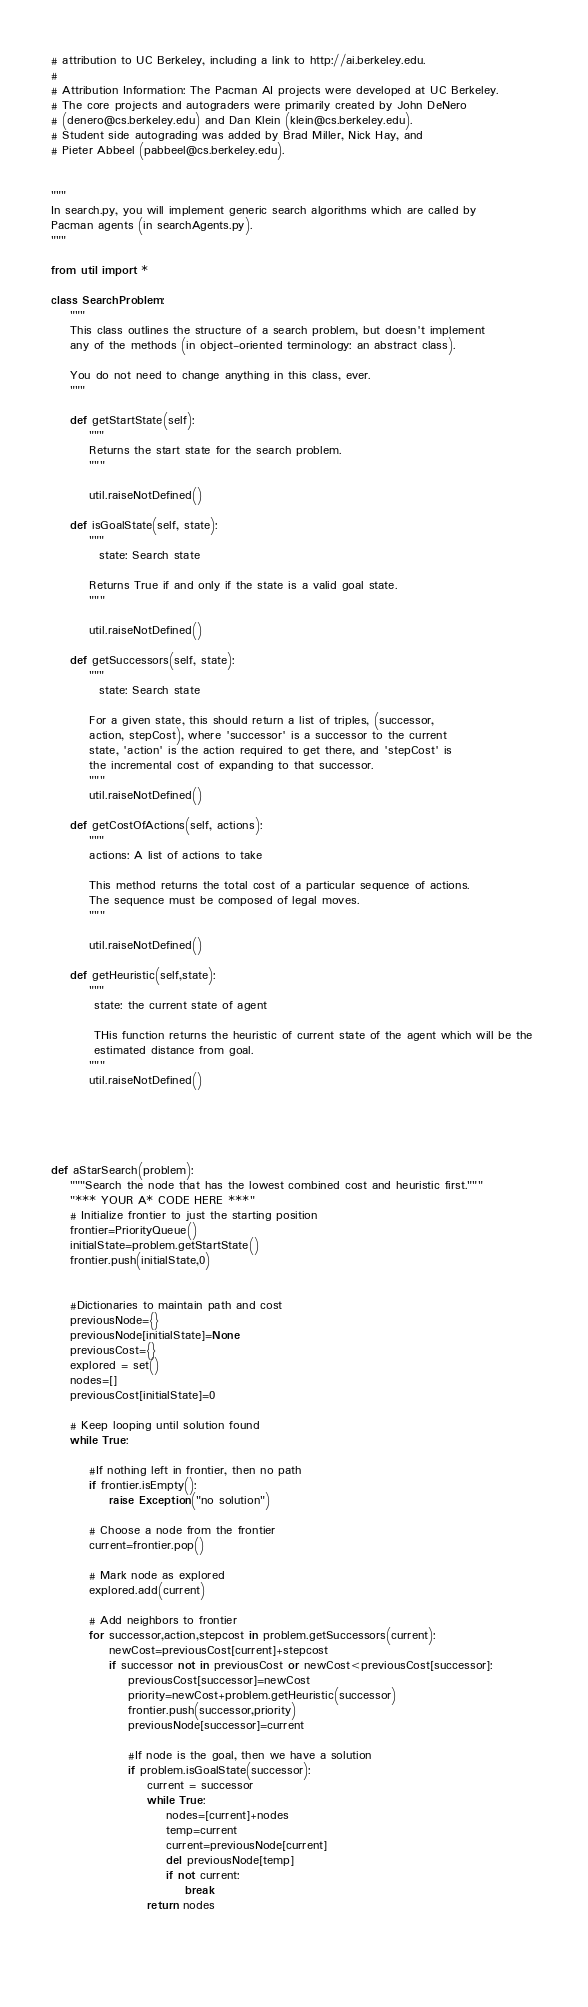Convert code to text. <code><loc_0><loc_0><loc_500><loc_500><_Python_># attribution to UC Berkeley, including a link to http://ai.berkeley.edu.
# 
# Attribution Information: The Pacman AI projects were developed at UC Berkeley.
# The core projects and autograders were primarily created by John DeNero
# (denero@cs.berkeley.edu) and Dan Klein (klein@cs.berkeley.edu).
# Student side autograding was added by Brad Miller, Nick Hay, and
# Pieter Abbeel (pabbeel@cs.berkeley.edu).


"""
In search.py, you will implement generic search algorithms which are called by
Pacman agents (in searchAgents.py).
"""

from util import *

class SearchProblem:
    """
    This class outlines the structure of a search problem, but doesn't implement
    any of the methods (in object-oriented terminology: an abstract class).

    You do not need to change anything in this class, ever.
    """

    def getStartState(self):
        """
        Returns the start state for the search problem.
        """
       
        util.raiseNotDefined()

    def isGoalState(self, state):
        """
          state: Search state

        Returns True if and only if the state is a valid goal state.
        """

        util.raiseNotDefined()

    def getSuccessors(self, state):
        """
          state: Search state

        For a given state, this should return a list of triples, (successor,
        action, stepCost), where 'successor' is a successor to the current
        state, 'action' is the action required to get there, and 'stepCost' is
        the incremental cost of expanding to that successor.
        """
        util.raiseNotDefined()

    def getCostOfActions(self, actions):
        """
        actions: A list of actions to take

        This method returns the total cost of a particular sequence of actions.
        The sequence must be composed of legal moves.
        """

        util.raiseNotDefined()
        
    def getHeuristic(self,state):
        """
         state: the current state of agent

         THis function returns the heuristic of current state of the agent which will be the 
         estimated distance from goal.
        """
        util.raiseNotDefined()





def aStarSearch(problem):
    """Search the node that has the lowest combined cost and heuristic first."""
    "*** YOUR A* CODE HERE ***"  
    # Initialize frontier to just the starting position
    frontier=PriorityQueue()
    initialState=problem.getStartState() 
    frontier.push(initialState,0)


    #Dictionaries to maintain path and cost
    previousNode={}
    previousNode[initialState]=None
    previousCost={}
    explored = set()
    nodes=[]
    previousCost[initialState]=0

    # Keep looping until solution found
    while True:

        #If nothing left in frontier, then no path
        if frontier.isEmpty():
            raise Exception("no solution")

        # Choose a node from the frontier
        current=frontier.pop()
        
        # Mark node as explored
        explored.add(current)
     
        # Add neighbors to frontier
        for successor,action,stepcost in problem.getSuccessors(current):
            newCost=previousCost[current]+stepcost
            if successor not in previousCost or newCost<previousCost[successor]:
                previousCost[successor]=newCost
                priority=newCost+problem.getHeuristic(successor)
                frontier.push(successor,priority)
                previousNode[successor]=current
                
                #If node is the goal, then we have a solution
                if problem.isGoalState(successor):
                    current = successor
                    while True:
                        nodes=[current]+nodes
                        temp=current
                        current=previousNode[current]
                        del previousNode[temp]
                        if not current:
                            break      
                    return nodes

    
                

</code> 